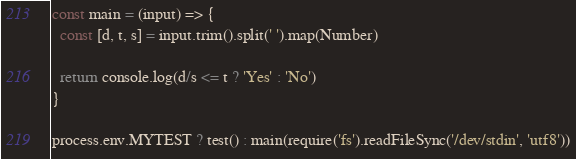Convert code to text. <code><loc_0><loc_0><loc_500><loc_500><_JavaScript_>const main = (input) => {
  const [d, t, s] = input.trim().split(' ').map(Number)

  return console.log(d/s <= t ? 'Yes' : 'No')
}

process.env.MYTEST ? test() : main(require('fs').readFileSync('/dev/stdin', 'utf8'))</code> 